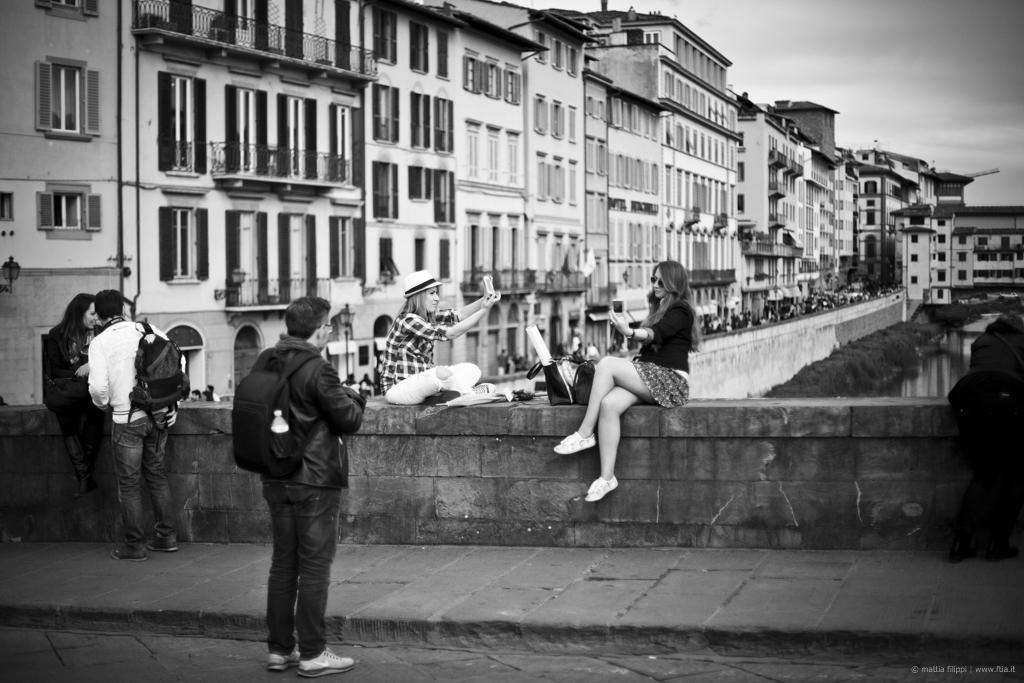What type of structures can be seen in the image? There are buildings in the image. Who or what else is present in the image? There are people in the image. What can be seen under the people and buildings? The ground is visible in the image. What natural element is also visible in the image? There is water visible in the image. What part of the natural environment is visible in the image? The sky is visible in the image. Where can you find text in the image? The text is in the bottom right corner of the image. How many chairs are visible in the image? There are no chairs present in the image. What type of tax is being discussed in the image? There is no discussion of tax in the image. 